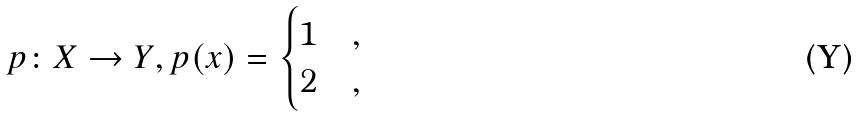<formula> <loc_0><loc_0><loc_500><loc_500>p \colon X \to Y , p ( x ) = \begin{cases} 1 & , \\ 2 & , \end{cases}</formula> 